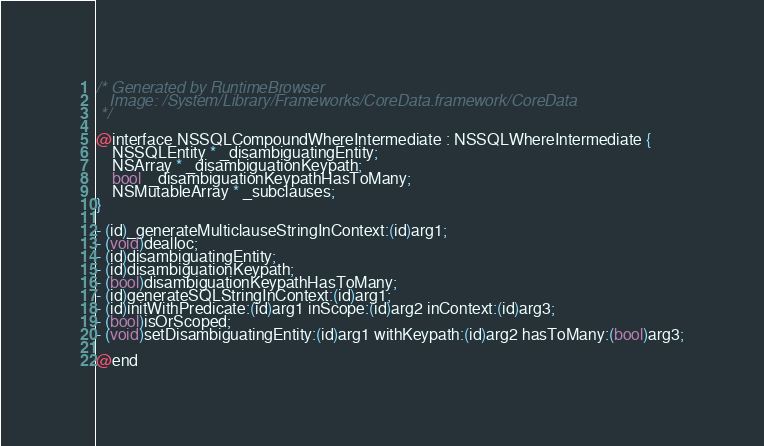<code> <loc_0><loc_0><loc_500><loc_500><_C_>/* Generated by RuntimeBrowser
   Image: /System/Library/Frameworks/CoreData.framework/CoreData
 */

@interface NSSQLCompoundWhereIntermediate : NSSQLWhereIntermediate {
    NSSQLEntity * _disambiguatingEntity;
    NSArray * _disambiguationKeypath;
    bool  _disambiguationKeypathHasToMany;
    NSMutableArray * _subclauses;
}

- (id)_generateMulticlauseStringInContext:(id)arg1;
- (void)dealloc;
- (id)disambiguatingEntity;
- (id)disambiguationKeypath;
- (bool)disambiguationKeypathHasToMany;
- (id)generateSQLStringInContext:(id)arg1;
- (id)initWithPredicate:(id)arg1 inScope:(id)arg2 inContext:(id)arg3;
- (bool)isOrScoped;
- (void)setDisambiguatingEntity:(id)arg1 withKeypath:(id)arg2 hasToMany:(bool)arg3;

@end
</code> 